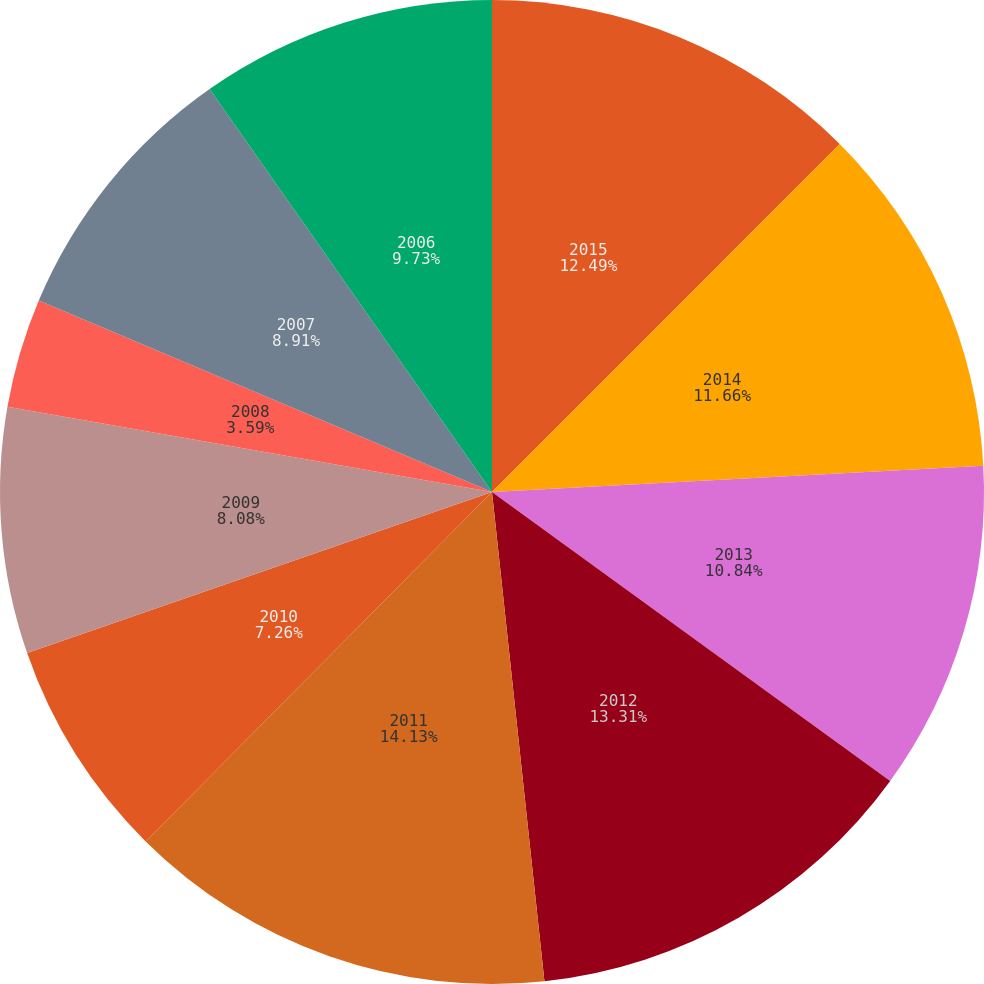Convert chart to OTSL. <chart><loc_0><loc_0><loc_500><loc_500><pie_chart><fcel>2015<fcel>2014<fcel>2013<fcel>2012<fcel>2011<fcel>2010<fcel>2009<fcel>2008<fcel>2007<fcel>2006<nl><fcel>12.49%<fcel>11.66%<fcel>10.84%<fcel>13.31%<fcel>14.13%<fcel>7.26%<fcel>8.08%<fcel>3.59%<fcel>8.91%<fcel>9.73%<nl></chart> 